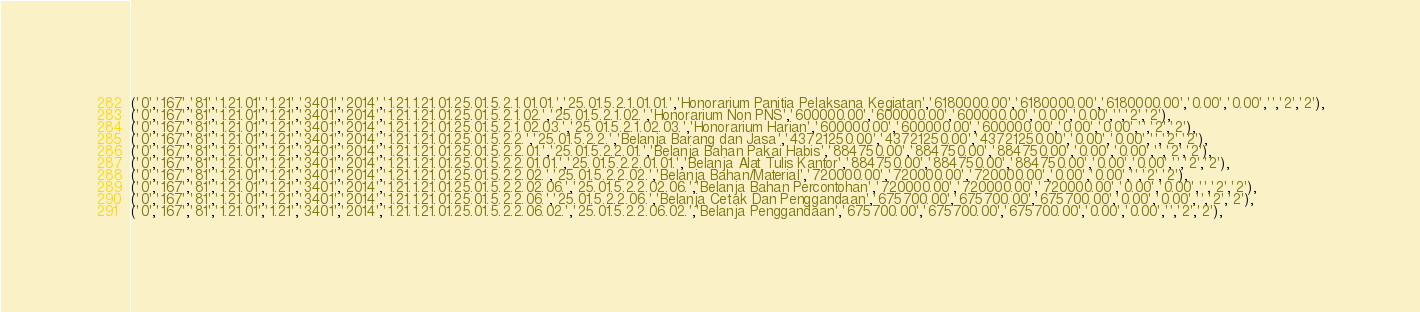Convert code to text. <code><loc_0><loc_0><loc_500><loc_500><_SQL_>('0','167','81','1.21.01','1.21','3401','2014','1.21.1.21.01.25.01.5.2.1.01.01.','25.01.5.2.1.01.01.','Honorarium Panitia Pelaksana Kegiatan','6180000.00','6180000.00','6180000.00','0.00','0.00','','2','2'),
('0','167','81','1.21.01','1.21','3401','2014','1.21.1.21.01.25.01.5.2.1.02.','25.01.5.2.1.02.','Honorarium Non PNS','600000.00','600000.00','600000.00','0.00','0.00','','2','2'),
('0','167','81','1.21.01','1.21','3401','2014','1.21.1.21.01.25.01.5.2.1.02.03.','25.01.5.2.1.02.03.','Honorarium Harian','600000.00','600000.00','600000.00','0.00','0.00','','2','2'),
('0','167','81','1.21.01','1.21','3401','2014','1.21.1.21.01.25.01.5.2.2.','25.01.5.2.2.','Belanja Barang dan Jasa','43721250.00','43721250.00','43721250.00','0.00','0.00','','2','2'),
('0','167','81','1.21.01','1.21','3401','2014','1.21.1.21.01.25.01.5.2.2.01.','25.01.5.2.2.01.','Belanja Bahan Pakai Habis','884750.00','884750.00','884750.00','0.00','0.00','','2','2'),
('0','167','81','1.21.01','1.21','3401','2014','1.21.1.21.01.25.01.5.2.2.01.01.','25.01.5.2.2.01.01.','Belanja Alat Tulis Kantor','884750.00','884750.00','884750.00','0.00','0.00','','2','2'),
('0','167','81','1.21.01','1.21','3401','2014','1.21.1.21.01.25.01.5.2.2.02.','25.01.5.2.2.02.','Belanja Bahan/Material','720000.00','720000.00','720000.00','0.00','0.00','','2','2'),
('0','167','81','1.21.01','1.21','3401','2014','1.21.1.21.01.25.01.5.2.2.02.06.','25.01.5.2.2.02.06.','Belanja Bahan Percontohan','720000.00','720000.00','720000.00','0.00','0.00','','2','2'),
('0','167','81','1.21.01','1.21','3401','2014','1.21.1.21.01.25.01.5.2.2.06.','25.01.5.2.2.06.','Belanja Cetak Dan Penggandaan','675700.00','675700.00','675700.00','0.00','0.00','','2','2'),
('0','167','81','1.21.01','1.21','3401','2014','1.21.1.21.01.25.01.5.2.2.06.02.','25.01.5.2.2.06.02.','Belanja Penggandaan','675700.00','675700.00','675700.00','0.00','0.00','','2','2'),</code> 